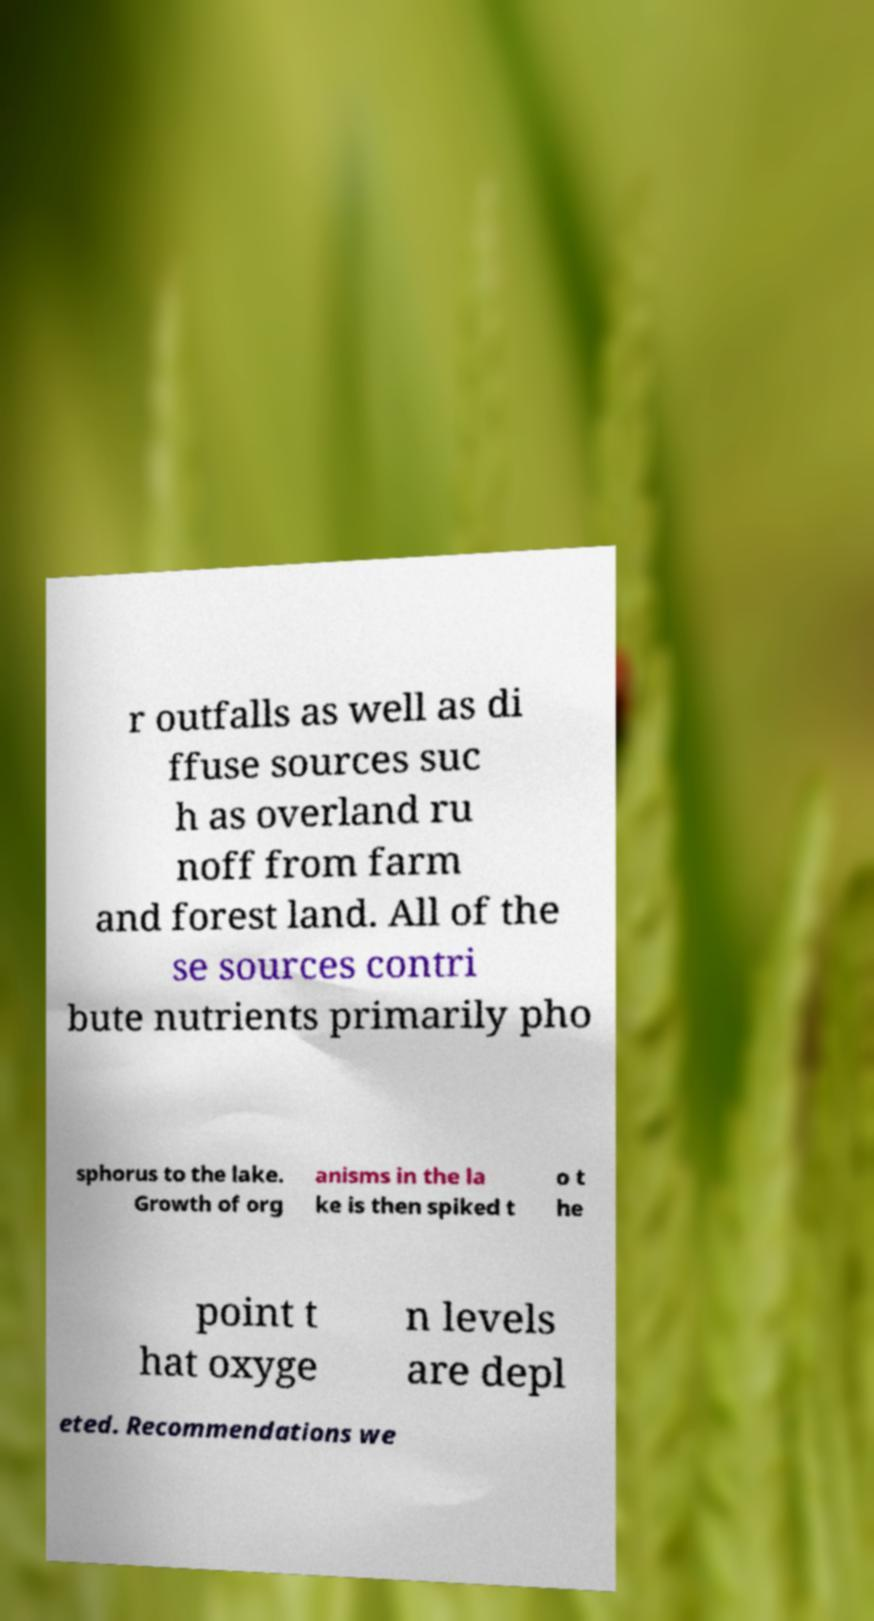Please read and relay the text visible in this image. What does it say? r outfalls as well as di ffuse sources suc h as overland ru noff from farm and forest land. All of the se sources contri bute nutrients primarily pho sphorus to the lake. Growth of org anisms in the la ke is then spiked t o t he point t hat oxyge n levels are depl eted. Recommendations we 